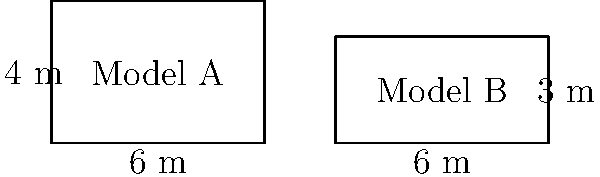As an entrepreneur running a self-driving taxi service, you're evaluating two new taxi models for your fleet. Model A has dimensions of 6m x 4m, while Model B has dimensions of 6m x 3m. Based on the congruence of their shapes, which statement is true? To determine if the two models are congruent, we need to compare their shapes and dimensions:

1. First, let's recall the definition of congruence: Two shapes are congruent if they have the same shape and size.

2. Both models are rectangles, so they have the same shape.

3. Now, let's compare their dimensions:
   - Model A: 6m x 4m
   - Model B: 6m x 3m

4. We can see that:
   - The length (6m) is the same for both models.
   - The width is different: 4m for Model A and 3m for Model B.

5. Since one of the dimensions (width) is different, the two models are not the same size.

6. Therefore, Model A and Model B are not congruent.

7. However, they do share one common dimension (length), which makes them similar but not congruent.
Answer: Model A and Model B are not congruent. 